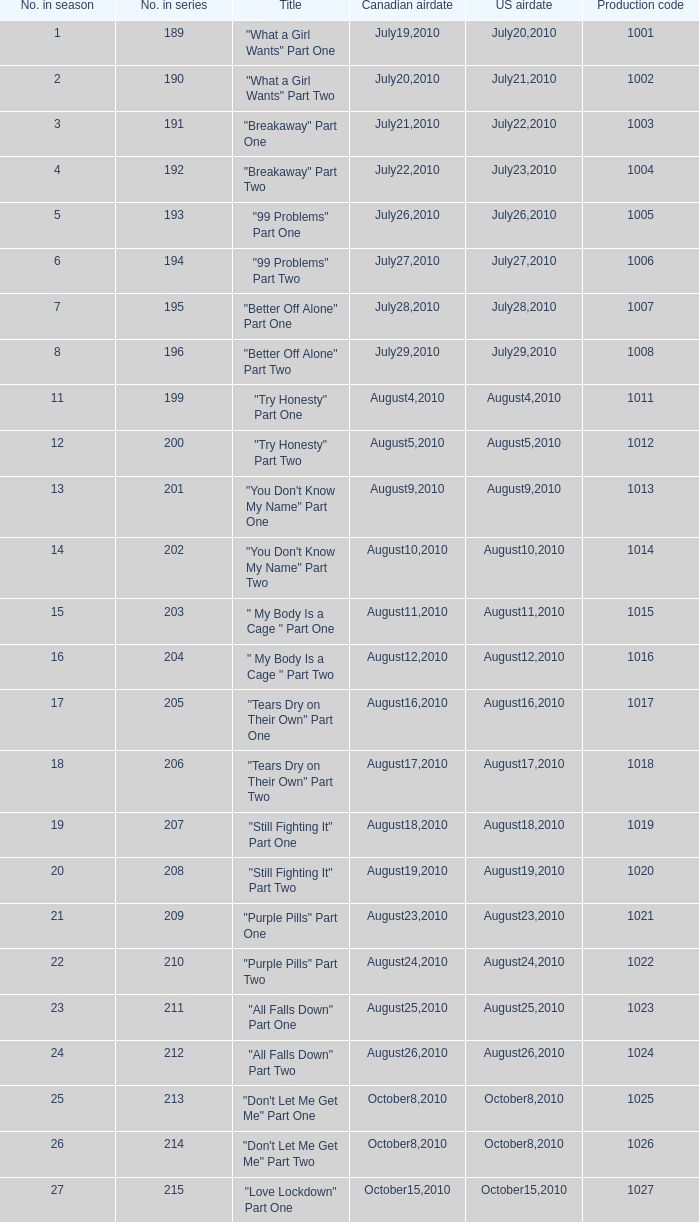What was the us airdate of "love lockdown" part one? October15,2010. 